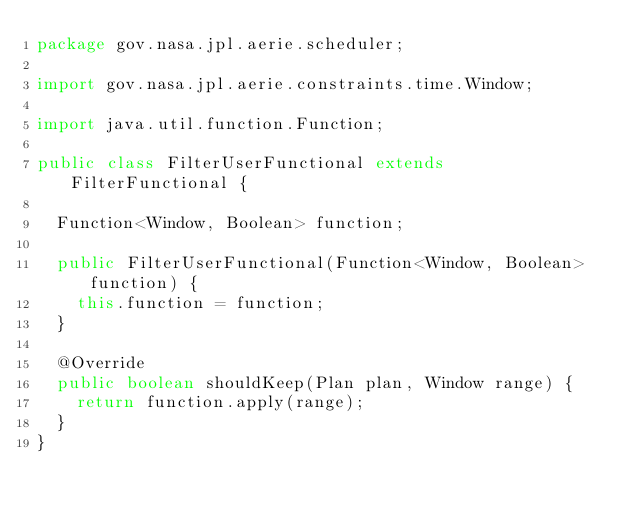<code> <loc_0><loc_0><loc_500><loc_500><_Java_>package gov.nasa.jpl.aerie.scheduler;

import gov.nasa.jpl.aerie.constraints.time.Window;

import java.util.function.Function;

public class FilterUserFunctional extends FilterFunctional {

  Function<Window, Boolean> function;

  public FilterUserFunctional(Function<Window, Boolean> function) {
    this.function = function;
  }

  @Override
  public boolean shouldKeep(Plan plan, Window range) {
    return function.apply(range);
  }
}
</code> 